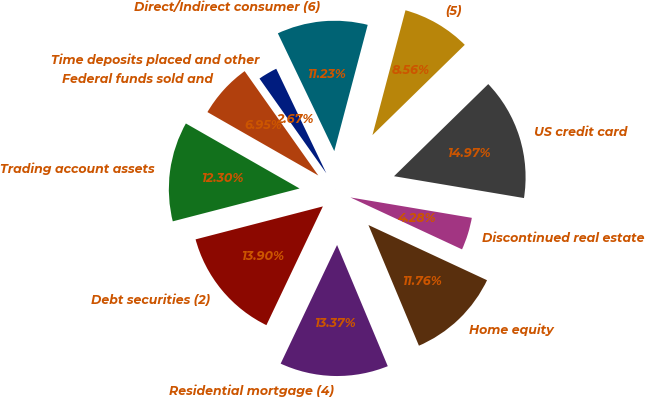<chart> <loc_0><loc_0><loc_500><loc_500><pie_chart><fcel>Time deposits placed and other<fcel>Federal funds sold and<fcel>Trading account assets<fcel>Debt securities (2)<fcel>Residential mortgage (4)<fcel>Home equity<fcel>Discontinued real estate<fcel>US credit card<fcel>(5)<fcel>Direct/Indirect consumer (6)<nl><fcel>2.67%<fcel>6.95%<fcel>12.3%<fcel>13.9%<fcel>13.37%<fcel>11.76%<fcel>4.28%<fcel>14.97%<fcel>8.56%<fcel>11.23%<nl></chart> 